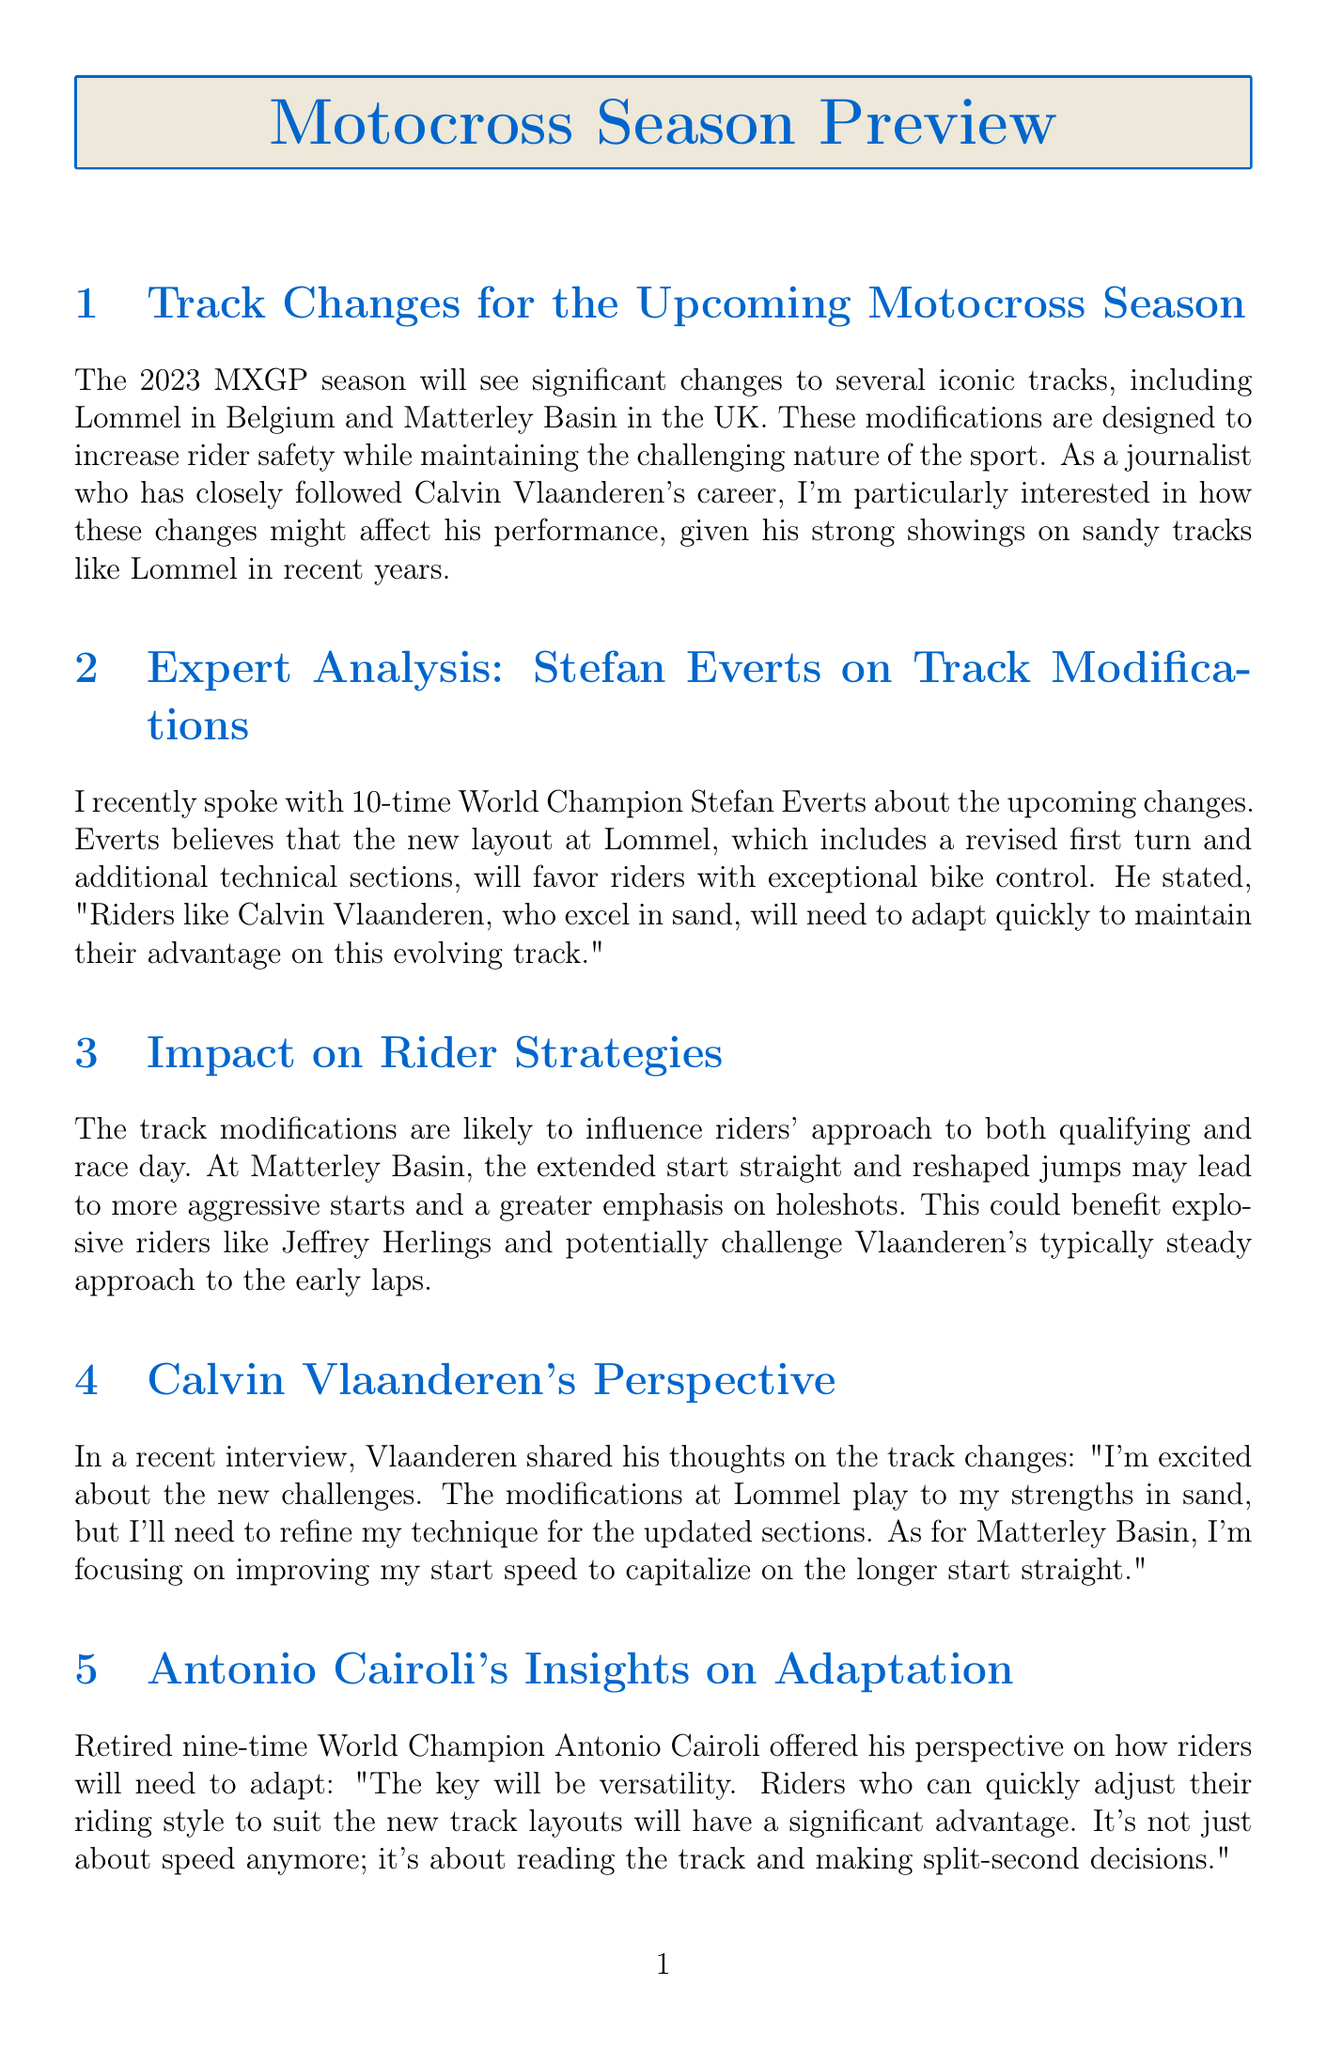What are the iconic tracks mentioned? The document mentions Lommel in Belgium and Matterley Basin in the UK as significant tracks.
Answer: Lommel, Matterley Basin Who provided expert analysis on track modifications? Stefan Everts is mentioned as providing expert analysis in the document.
Answer: Stefan Everts What is Calvin Vlaanderen focusing on for Matterley Basin? Vlaanderen stated he is focusing on improving his start speed for the longer start straight.
Answer: Improving start speed How many World Championships did Antonio Cairoli win? Antonio Cairoli is described as a nine-time World Champion in the document.
Answer: Nine What is a key strategy mentioned for riders adapting to track changes? The document notes that versatility in adapting riding style to new layouts is crucial.
Answer: Versatility What aspect of training are teams emphasizing due to track modifications? Teams are focusing on explosive starts during pre-season training preparation.
Answer: Explosive starts How many technical sections are added at Lommel? The content mentions additional technical sections at Lommel but does not specify a number.
Answer: Not specified What implication do track changes have on the championship standings? The changes may lead to a more unpredictable and exciting season according to the document.
Answer: More unpredictable season 